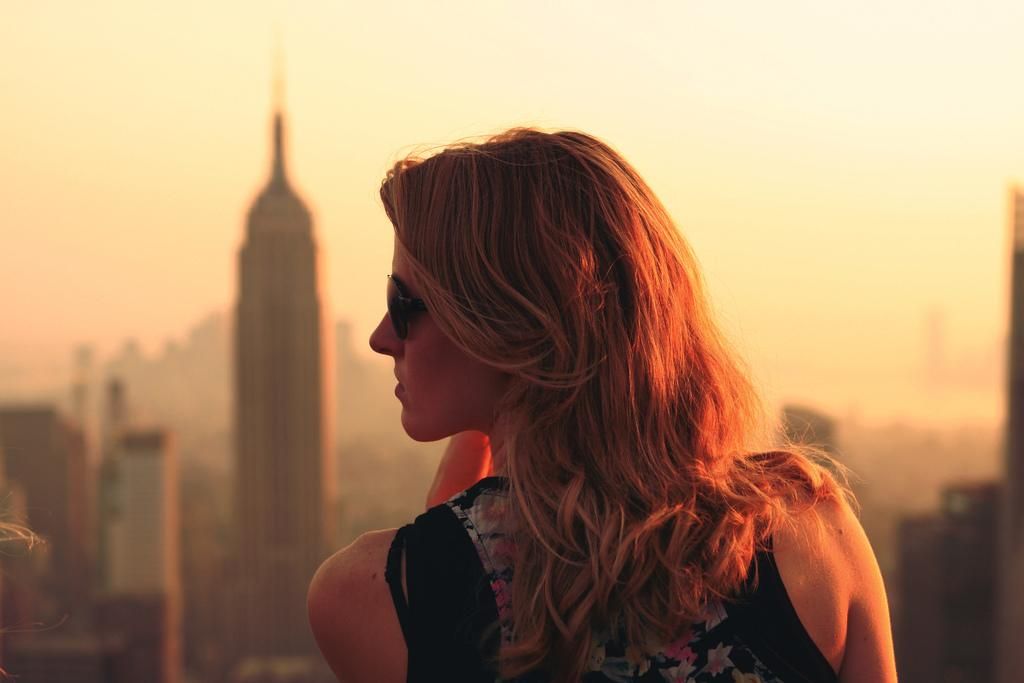Who is present in the image? There is a woman in the image. What can be seen in the distance behind the woman? There are buildings in the background of the image. What type of hat is the woman wearing in the image? There is no hat visible in the image. What kind of trouble is the woman experiencing in the image? There is no indication of trouble in the image; the woman appears to be standing still. 